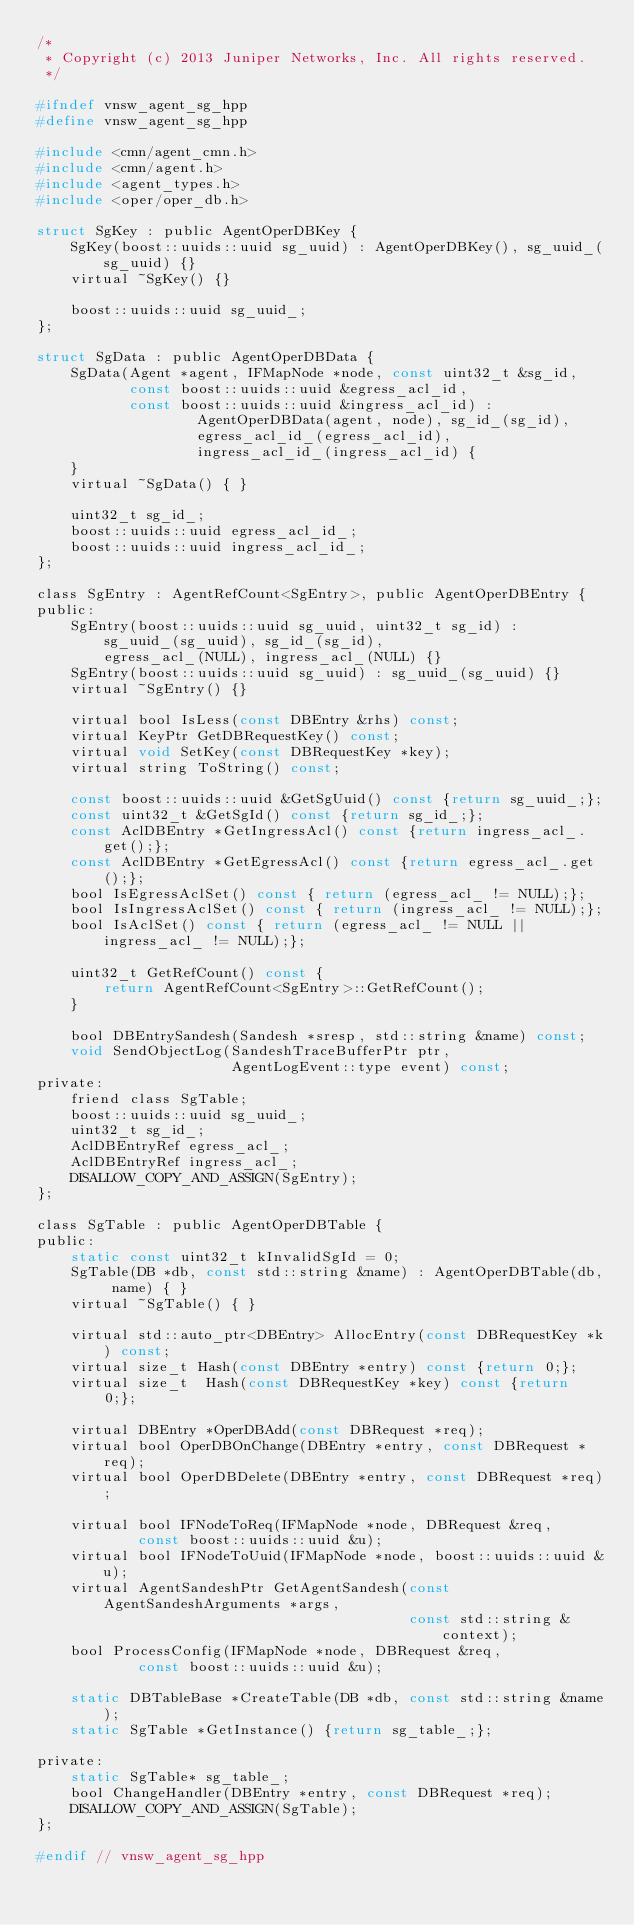<code> <loc_0><loc_0><loc_500><loc_500><_C_>/*
 * Copyright (c) 2013 Juniper Networks, Inc. All rights reserved.
 */

#ifndef vnsw_agent_sg_hpp
#define vnsw_agent_sg_hpp

#include <cmn/agent_cmn.h>
#include <cmn/agent.h>
#include <agent_types.h>
#include <oper/oper_db.h>

struct SgKey : public AgentOperDBKey {
    SgKey(boost::uuids::uuid sg_uuid) : AgentOperDBKey(), sg_uuid_(sg_uuid) {}
    virtual ~SgKey() {}

    boost::uuids::uuid sg_uuid_;
};

struct SgData : public AgentOperDBData {
    SgData(Agent *agent, IFMapNode *node, const uint32_t &sg_id,
           const boost::uuids::uuid &egress_acl_id,
           const boost::uuids::uuid &ingress_acl_id) :
                   AgentOperDBData(agent, node), sg_id_(sg_id),
                   egress_acl_id_(egress_acl_id),
                   ingress_acl_id_(ingress_acl_id) {
    }
    virtual ~SgData() { }

    uint32_t sg_id_;
    boost::uuids::uuid egress_acl_id_;
    boost::uuids::uuid ingress_acl_id_;
};

class SgEntry : AgentRefCount<SgEntry>, public AgentOperDBEntry {
public:
    SgEntry(boost::uuids::uuid sg_uuid, uint32_t sg_id) :
        sg_uuid_(sg_uuid), sg_id_(sg_id),
        egress_acl_(NULL), ingress_acl_(NULL) {}
    SgEntry(boost::uuids::uuid sg_uuid) : sg_uuid_(sg_uuid) {}
    virtual ~SgEntry() {}

    virtual bool IsLess(const DBEntry &rhs) const;
    virtual KeyPtr GetDBRequestKey() const;
    virtual void SetKey(const DBRequestKey *key);
    virtual string ToString() const;

    const boost::uuids::uuid &GetSgUuid() const {return sg_uuid_;};
    const uint32_t &GetSgId() const {return sg_id_;};
    const AclDBEntry *GetIngressAcl() const {return ingress_acl_.get();};
    const AclDBEntry *GetEgressAcl() const {return egress_acl_.get();};
    bool IsEgressAclSet() const { return (egress_acl_ != NULL);};
    bool IsIngressAclSet() const { return (ingress_acl_ != NULL);};
    bool IsAclSet() const { return (egress_acl_ != NULL || ingress_acl_ != NULL);};

    uint32_t GetRefCount() const {
        return AgentRefCount<SgEntry>::GetRefCount();
    }

    bool DBEntrySandesh(Sandesh *sresp, std::string &name) const;
    void SendObjectLog(SandeshTraceBufferPtr ptr,
                       AgentLogEvent::type event) const;
private:
    friend class SgTable;
    boost::uuids::uuid sg_uuid_;
    uint32_t sg_id_;
    AclDBEntryRef egress_acl_;
    AclDBEntryRef ingress_acl_;
    DISALLOW_COPY_AND_ASSIGN(SgEntry);
};

class SgTable : public AgentOperDBTable {
public:
    static const uint32_t kInvalidSgId = 0;
    SgTable(DB *db, const std::string &name) : AgentOperDBTable(db, name) { }
    virtual ~SgTable() { }

    virtual std::auto_ptr<DBEntry> AllocEntry(const DBRequestKey *k) const;
    virtual size_t Hash(const DBEntry *entry) const {return 0;};
    virtual size_t  Hash(const DBRequestKey *key) const {return 0;};

    virtual DBEntry *OperDBAdd(const DBRequest *req);
    virtual bool OperDBOnChange(DBEntry *entry, const DBRequest *req);
    virtual bool OperDBDelete(DBEntry *entry, const DBRequest *req);

    virtual bool IFNodeToReq(IFMapNode *node, DBRequest &req,
            const boost::uuids::uuid &u);
    virtual bool IFNodeToUuid(IFMapNode *node, boost::uuids::uuid &u);
    virtual AgentSandeshPtr GetAgentSandesh(const AgentSandeshArguments *args,
                                            const std::string &context);
    bool ProcessConfig(IFMapNode *node, DBRequest &req,
            const boost::uuids::uuid &u);

    static DBTableBase *CreateTable(DB *db, const std::string &name);
    static SgTable *GetInstance() {return sg_table_;};

private:
    static SgTable* sg_table_;
    bool ChangeHandler(DBEntry *entry, const DBRequest *req);
    DISALLOW_COPY_AND_ASSIGN(SgTable);
};

#endif // vnsw_agent_sg_hpp
</code> 